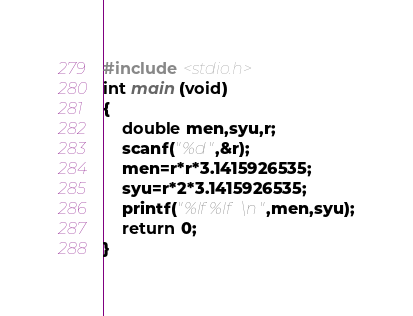<code> <loc_0><loc_0><loc_500><loc_500><_C_>#include <stdio.h>
int main (void)
{
	double men,syu,r;
	scanf("%d",&r);
	men=r*r*3.1415926535;
	syu=r*2*3.1415926535;
	printf("%lf %lf\n",men,syu);
	return 0;
}</code> 